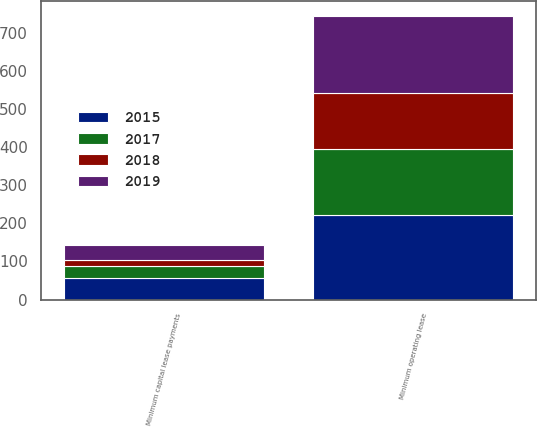<chart> <loc_0><loc_0><loc_500><loc_500><stacked_bar_chart><ecel><fcel>Minimum operating lease<fcel>Minimum capital lease payments<nl><fcel>2015<fcel>221<fcel>56<nl><fcel>2019<fcel>203<fcel>40<nl><fcel>2017<fcel>175<fcel>33<nl><fcel>2018<fcel>146<fcel>14<nl></chart> 